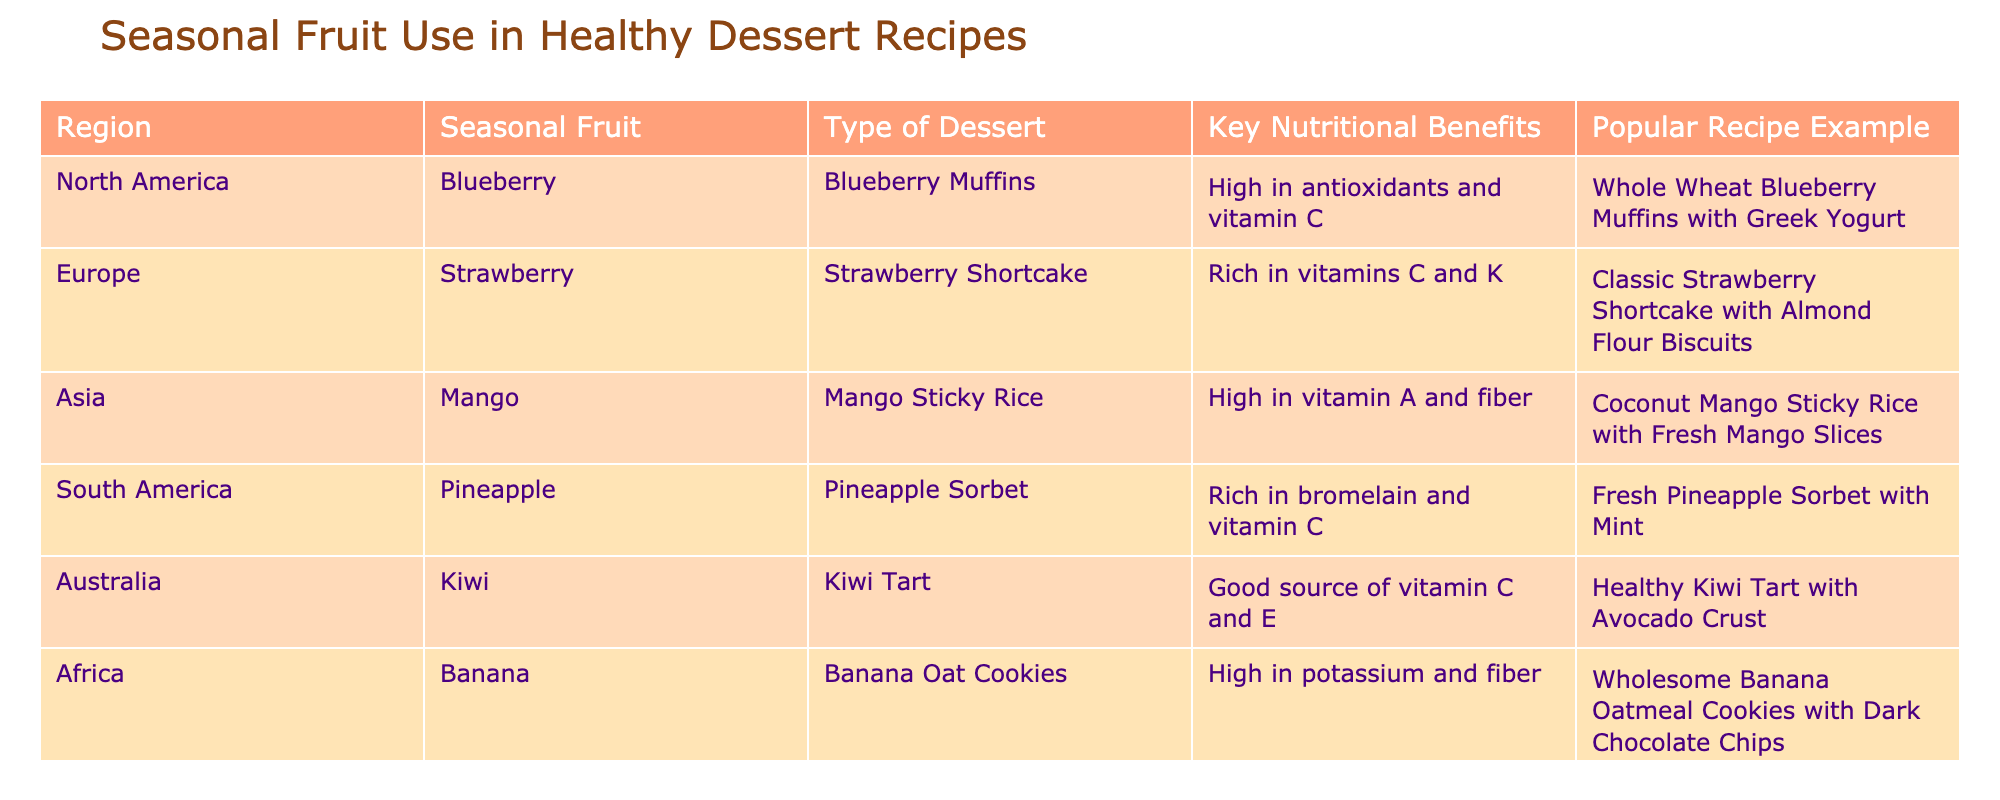What is the seasonal fruit used in North American dessert recipes? The table indicates that the seasonal fruit used in North American dessert recipes is blueberry.
Answer: Blueberry Which dessert type is associated with bananas in Africa? According to the table, the dessert type associated with bananas in Africa is Banana Oat Cookies.
Answer: Banana Oat Cookies Which region uses pineapple in their healthy dessert recipe, and what is a key nutritional benefit of this fruit? The table states that South America uses pineapple in their healthy dessert recipes, and a key nutritional benefit is that pineapple is rich in bromelain and vitamin C.
Answer: South America, rich in bromelain and vitamin C What dessert contains kiwi and what are its nutritional benefits? The table shows that the dessert containing kiwi is Kiwi Tart, which is a good source of vitamin C and E.
Answer: Kiwi Tart, good source of vitamin C and E Which dessert has the highest number of vitamins listed in its nutritional benefits, and what are those vitamins? Comparing the listed desserts, we see that Strawberry Shortcake is rich in vitamins C and K. Thus, it has two vitamins mentioned, which is the highest among the listed desserts.
Answer: Strawberry Shortcake, vitamins C and K Does Europe feature a dessert that is high in fiber? The table indicates that European desserts, specifically Strawberry Shortcake, do not mention high fiber content; therefore, it does not feature a dessert that is high in fiber.
Answer: No How many different types of desserts are listed in the table? By counting each unique type of dessert in the table (Blueberry Muffins, Strawberry Shortcake, Mango Sticky Rice, Pineapple Sorbet, Kiwi Tart, Banana Oat Cookies), we find there are six different types of desserts.
Answer: 6 What is the relationship between the regions that use mango and banana in desserts? Analyzing the table, we find that mango is used in desserts from Asia, while banana is used in desserts from Africa. Therefore, they are related as they come from different continents but are both highlighted in healthy dessert recipes.
Answer: Different continents, Asia and Africa What is the average number of key nutritional benefits mentioned for the desserts listed in the table? The desserts listed have varied key nutritional benefits: 1 for Blueberry Muffins, 2 for Strawberry Shortcake, 2 for Mango Sticky Rice, 2 for Pineapple Sorbet, 2 for Kiwi Tart, and 2 for Banana Oat Cookies. To find the average, we sum the numbers: 1 + 2 + 2 + 2 + 2 + 2 = 11, and since there are 6 desserts, the average is 11/6 ≈ 1.83.
Answer: Approximately 1.83 